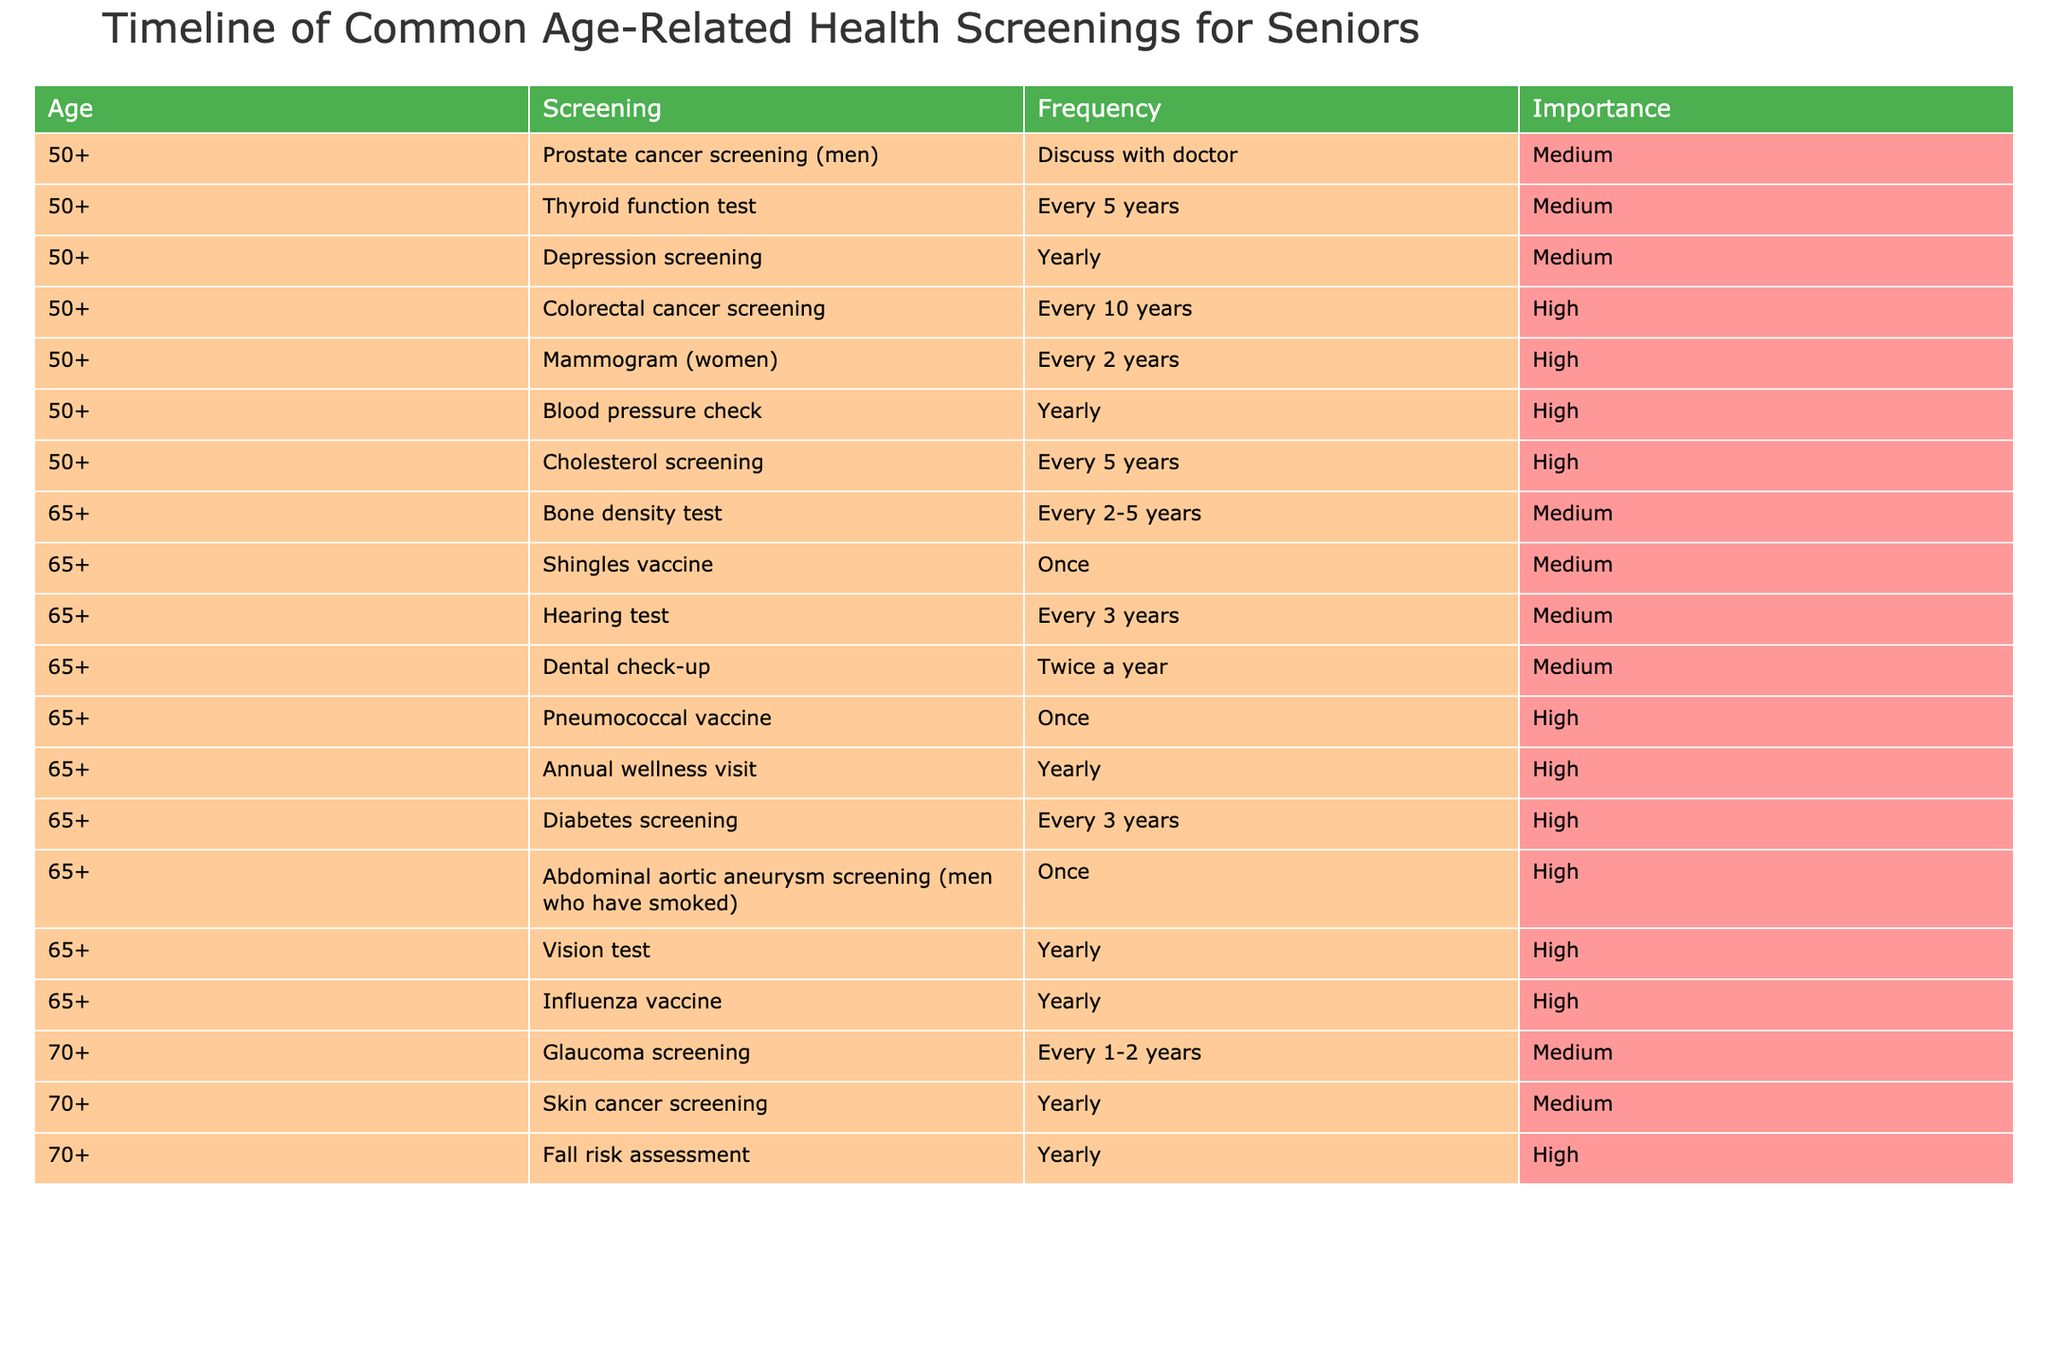What is the frequency of colorectal cancer screening for seniors? The table states that for individuals aged 50 and above, the frequency of colorectal cancer screening is every 10 years.
Answer: Every 10 years How often should women aged 50 and above get a mammogram? According to the table, women in this age group should have a mammogram every 2 years.
Answer: Every 2 years Is there a recommendation for prostate cancer screening for men aged 50 and above? The table indicates that men aged 50 and older should discuss prostate cancer screening with their doctor, implying that there's no standard scheduled frequency.
Answer: Discuss with doctor What are the total number of screenings listed for seniors aged 65 and older? By examining the table, there are 9 different screenings mentioned for seniors aged 65 and above: bone density test, pneumococcal vaccine, annual wellness visit, glaucoma screening, shingles vaccine, hearing test, diabetes screening, vision test, and abdominal aortic aneurysm screening. Therefore, the total is 9.
Answer: 9 What is the range of years for the frequency of the bone density test for seniors 65 and older? The table indicates that the bone density test should be done every 2-5 years for seniors in this age group. This shows variability in the frequency based on individual circumstances.
Answer: Every 2-5 years True or false: The influenza vaccine is required yearly for seniors. The table confirms that the influenza vaccine is indicated to be given yearly for seniors, making this statement true.
Answer: True What is the importance level of the diabetes screening for seniors aged 65 and above compared to glaucoma screening in the same age group? From the table, the diabetes screening is marked as high importance, while the glaucoma screening is tagged as medium importance. Thus, diabetes screening is more important than glaucoma screening.
Answer: Higher How many screenings are recommended to be done yearly for seniors aged 70 and above? In the table, there are three screenings for seniors aged 70 and above that occur yearly: skin cancer screening, fall risk assessment, and annual wellness visit. Thus, the total is 3.
Answer: 3 Which screening do seniors need to have twice a year? The table states that dental check-ups are to be done twice a year for seniors; this is the only screening mentioned with this frequency.
Answer: Dental check-up 